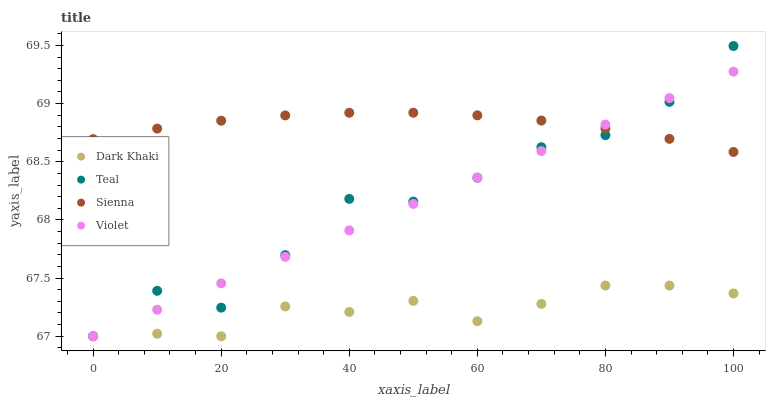Does Dark Khaki have the minimum area under the curve?
Answer yes or no. Yes. Does Sienna have the maximum area under the curve?
Answer yes or no. Yes. Does Teal have the minimum area under the curve?
Answer yes or no. No. Does Teal have the maximum area under the curve?
Answer yes or no. No. Is Violet the smoothest?
Answer yes or no. Yes. Is Teal the roughest?
Answer yes or no. Yes. Is Sienna the smoothest?
Answer yes or no. No. Is Sienna the roughest?
Answer yes or no. No. Does Dark Khaki have the lowest value?
Answer yes or no. Yes. Does Sienna have the lowest value?
Answer yes or no. No. Does Teal have the highest value?
Answer yes or no. Yes. Does Sienna have the highest value?
Answer yes or no. No. Is Dark Khaki less than Sienna?
Answer yes or no. Yes. Is Sienna greater than Dark Khaki?
Answer yes or no. Yes. Does Sienna intersect Violet?
Answer yes or no. Yes. Is Sienna less than Violet?
Answer yes or no. No. Is Sienna greater than Violet?
Answer yes or no. No. Does Dark Khaki intersect Sienna?
Answer yes or no. No. 